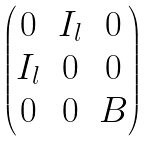<formula> <loc_0><loc_0><loc_500><loc_500>\begin{pmatrix} 0 & I _ { l } & 0 \\ I _ { l } & 0 & 0 \\ 0 & 0 & B \end{pmatrix}</formula> 